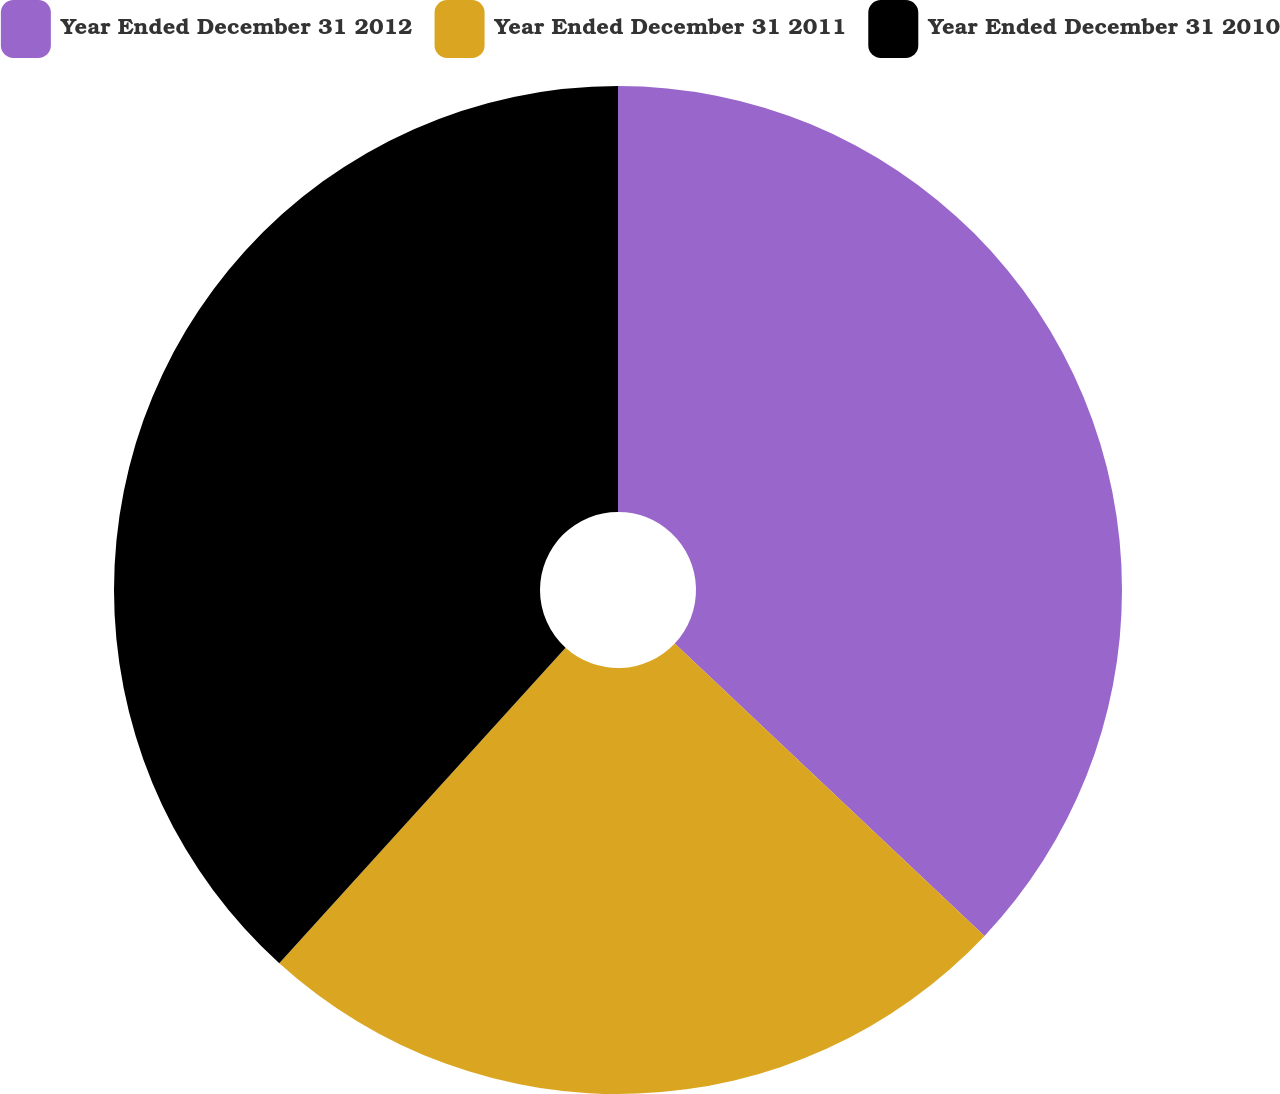Convert chart to OTSL. <chart><loc_0><loc_0><loc_500><loc_500><pie_chart><fcel>Year Ended December 31 2012<fcel>Year Ended December 31 2011<fcel>Year Ended December 31 2010<nl><fcel>37.04%<fcel>24.69%<fcel>38.27%<nl></chart> 